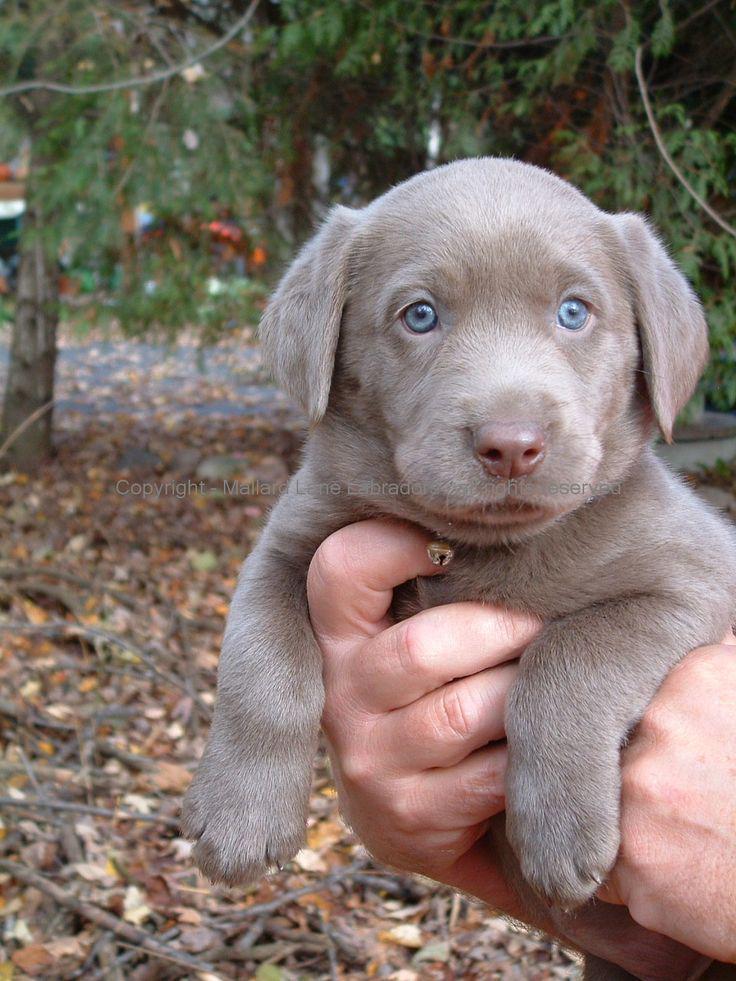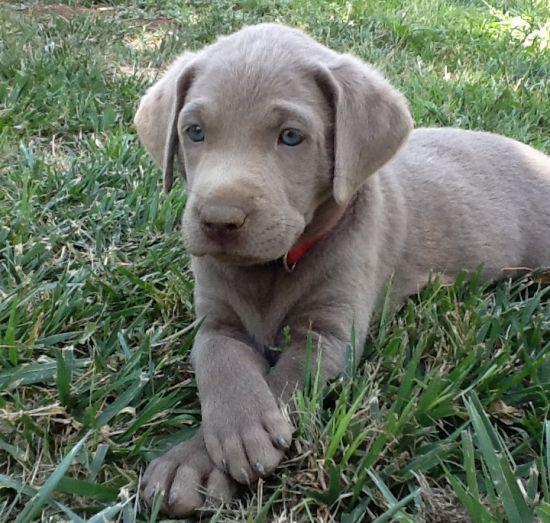The first image is the image on the left, the second image is the image on the right. For the images displayed, is the sentence "Someone is holding one of the dogs." factually correct? Answer yes or no. Yes. The first image is the image on the left, the second image is the image on the right. Assess this claim about the two images: "An image shows a blue-eyed gray dog wearing a red collar.". Correct or not? Answer yes or no. Yes. 